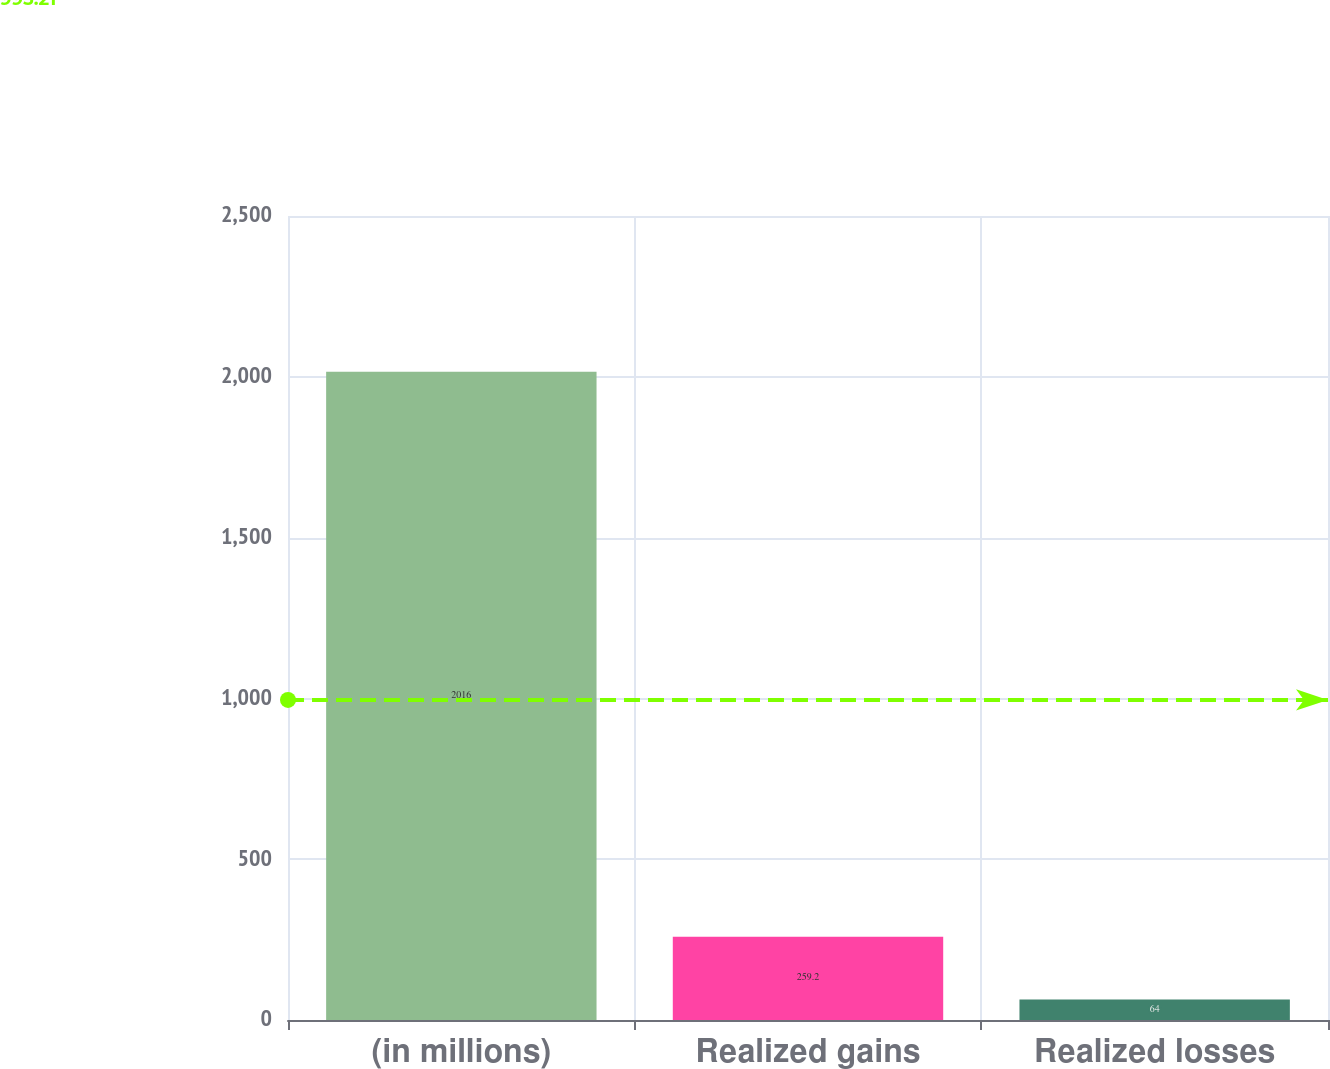<chart> <loc_0><loc_0><loc_500><loc_500><bar_chart><fcel>(in millions)<fcel>Realized gains<fcel>Realized losses<nl><fcel>2016<fcel>259.2<fcel>64<nl></chart> 